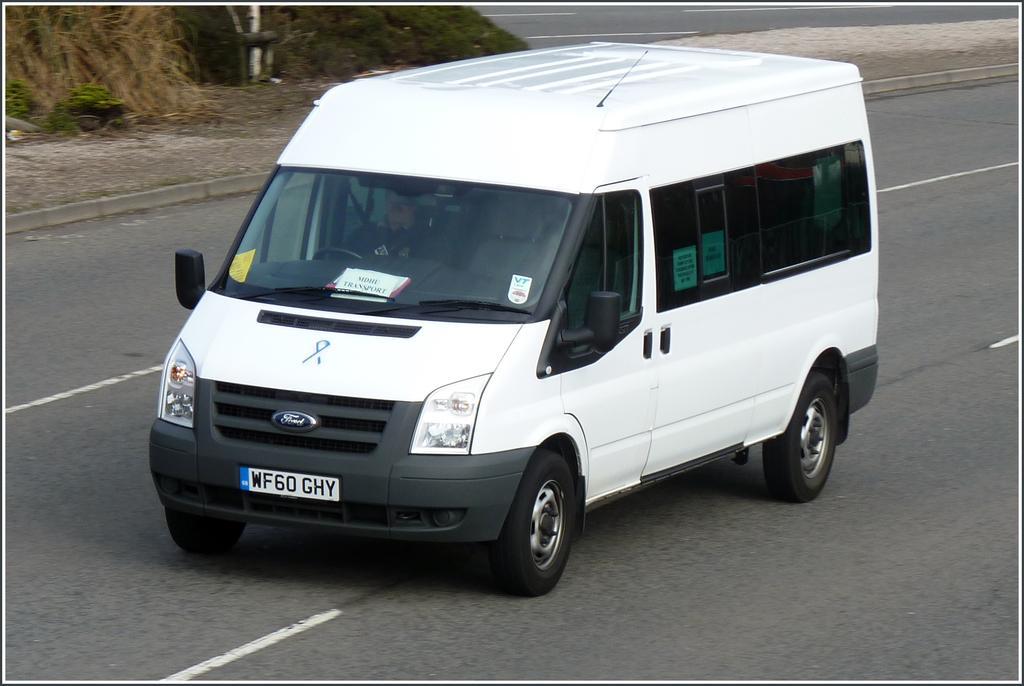Describe this image in one or two sentences. In this image we can see a person sitting inside a vehicle parked on the road. In the background, we can see a pole and some plants. 